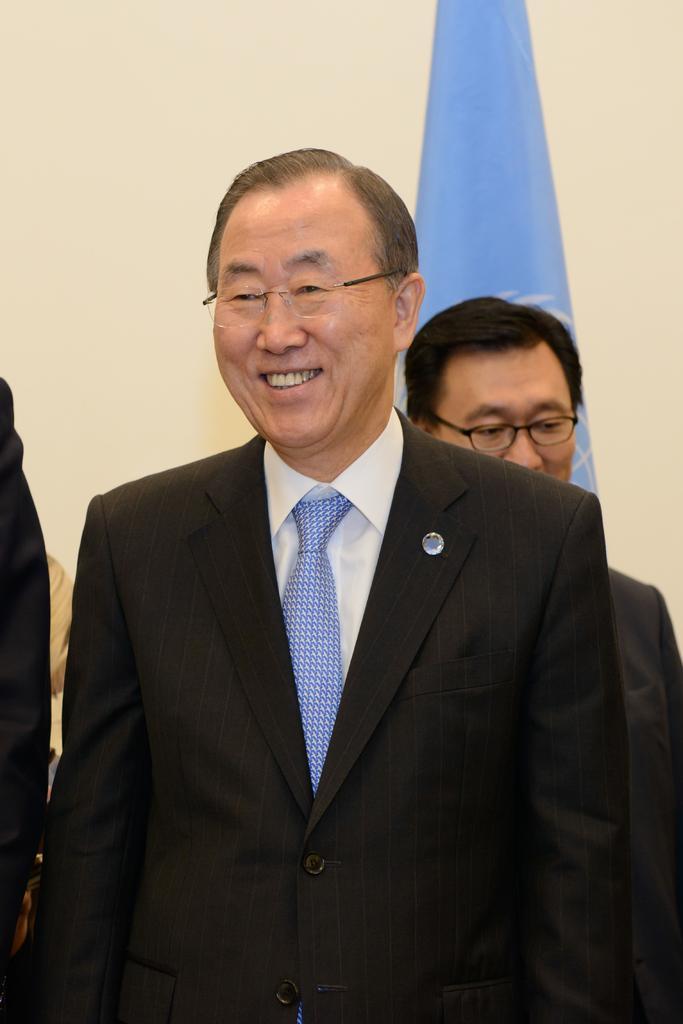Please provide a concise description of this image. In this image I can see two persons standing. 